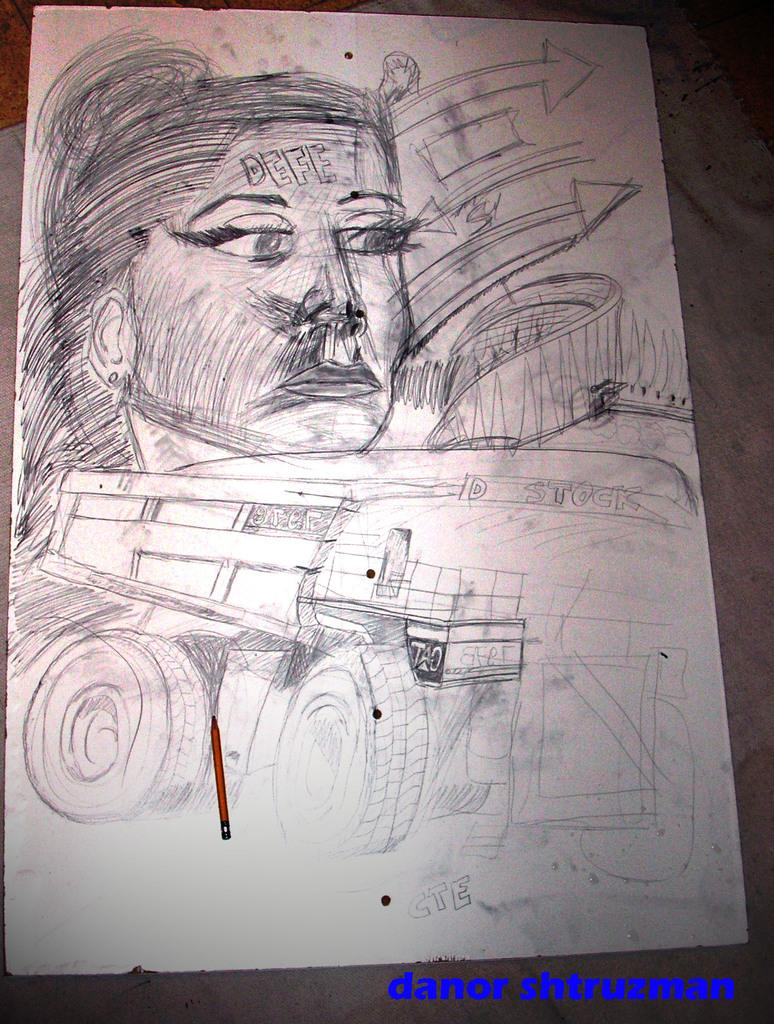What is depicted in the image? There is a sketch of a person in the image. What else can be seen in the image besides the sketch? There are vehicles in the image. What is the background color of the sheet on which the image is drawn? The image is on a white color sheet. Are there any insects crawling on the sketch in the image? There are no insects visible in the image; it only features a sketch of a person and some vehicles. 